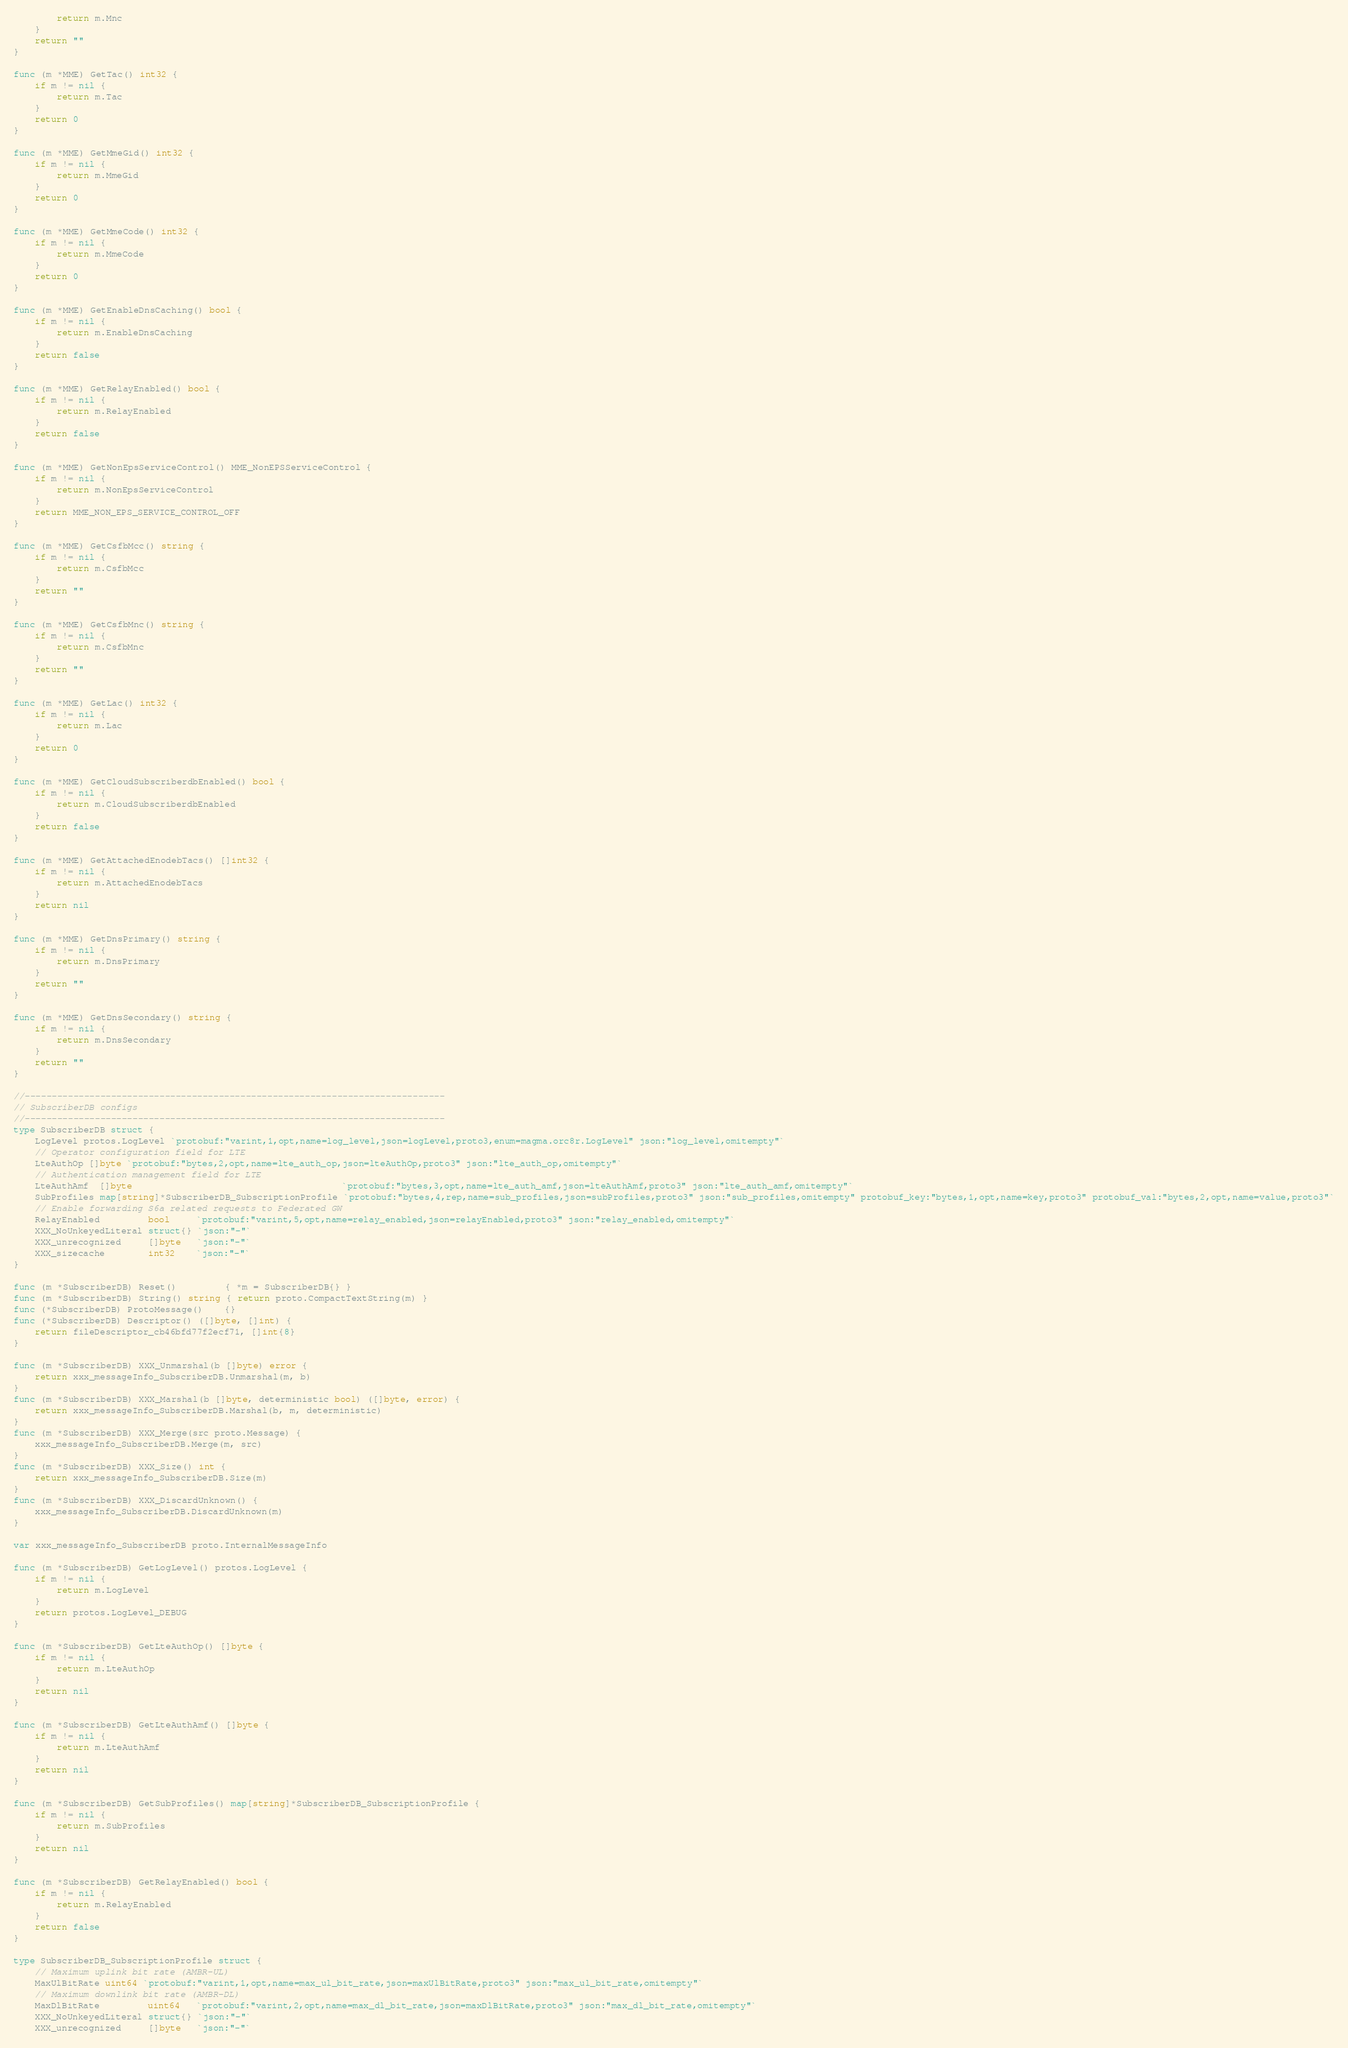<code> <loc_0><loc_0><loc_500><loc_500><_Go_>		return m.Mnc
	}
	return ""
}

func (m *MME) GetTac() int32 {
	if m != nil {
		return m.Tac
	}
	return 0
}

func (m *MME) GetMmeGid() int32 {
	if m != nil {
		return m.MmeGid
	}
	return 0
}

func (m *MME) GetMmeCode() int32 {
	if m != nil {
		return m.MmeCode
	}
	return 0
}

func (m *MME) GetEnableDnsCaching() bool {
	if m != nil {
		return m.EnableDnsCaching
	}
	return false
}

func (m *MME) GetRelayEnabled() bool {
	if m != nil {
		return m.RelayEnabled
	}
	return false
}

func (m *MME) GetNonEpsServiceControl() MME_NonEPSServiceControl {
	if m != nil {
		return m.NonEpsServiceControl
	}
	return MME_NON_EPS_SERVICE_CONTROL_OFF
}

func (m *MME) GetCsfbMcc() string {
	if m != nil {
		return m.CsfbMcc
	}
	return ""
}

func (m *MME) GetCsfbMnc() string {
	if m != nil {
		return m.CsfbMnc
	}
	return ""
}

func (m *MME) GetLac() int32 {
	if m != nil {
		return m.Lac
	}
	return 0
}

func (m *MME) GetCloudSubscriberdbEnabled() bool {
	if m != nil {
		return m.CloudSubscriberdbEnabled
	}
	return false
}

func (m *MME) GetAttachedEnodebTacs() []int32 {
	if m != nil {
		return m.AttachedEnodebTacs
	}
	return nil
}

func (m *MME) GetDnsPrimary() string {
	if m != nil {
		return m.DnsPrimary
	}
	return ""
}

func (m *MME) GetDnsSecondary() string {
	if m != nil {
		return m.DnsSecondary
	}
	return ""
}

//------------------------------------------------------------------------------
// SubscriberDB configs
//------------------------------------------------------------------------------
type SubscriberDB struct {
	LogLevel protos.LogLevel `protobuf:"varint,1,opt,name=log_level,json=logLevel,proto3,enum=magma.orc8r.LogLevel" json:"log_level,omitempty"`
	// Operator configuration field for LTE
	LteAuthOp []byte `protobuf:"bytes,2,opt,name=lte_auth_op,json=lteAuthOp,proto3" json:"lte_auth_op,omitempty"`
	// Authentication management field for LTE
	LteAuthAmf  []byte                                       `protobuf:"bytes,3,opt,name=lte_auth_amf,json=lteAuthAmf,proto3" json:"lte_auth_amf,omitempty"`
	SubProfiles map[string]*SubscriberDB_SubscriptionProfile `protobuf:"bytes,4,rep,name=sub_profiles,json=subProfiles,proto3" json:"sub_profiles,omitempty" protobuf_key:"bytes,1,opt,name=key,proto3" protobuf_val:"bytes,2,opt,name=value,proto3"`
	// Enable forwarding S6a related requests to Federated GW
	RelayEnabled         bool     `protobuf:"varint,5,opt,name=relay_enabled,json=relayEnabled,proto3" json:"relay_enabled,omitempty"`
	XXX_NoUnkeyedLiteral struct{} `json:"-"`
	XXX_unrecognized     []byte   `json:"-"`
	XXX_sizecache        int32    `json:"-"`
}

func (m *SubscriberDB) Reset()         { *m = SubscriberDB{} }
func (m *SubscriberDB) String() string { return proto.CompactTextString(m) }
func (*SubscriberDB) ProtoMessage()    {}
func (*SubscriberDB) Descriptor() ([]byte, []int) {
	return fileDescriptor_cb46bfd77f2ecf71, []int{8}
}

func (m *SubscriberDB) XXX_Unmarshal(b []byte) error {
	return xxx_messageInfo_SubscriberDB.Unmarshal(m, b)
}
func (m *SubscriberDB) XXX_Marshal(b []byte, deterministic bool) ([]byte, error) {
	return xxx_messageInfo_SubscriberDB.Marshal(b, m, deterministic)
}
func (m *SubscriberDB) XXX_Merge(src proto.Message) {
	xxx_messageInfo_SubscriberDB.Merge(m, src)
}
func (m *SubscriberDB) XXX_Size() int {
	return xxx_messageInfo_SubscriberDB.Size(m)
}
func (m *SubscriberDB) XXX_DiscardUnknown() {
	xxx_messageInfo_SubscriberDB.DiscardUnknown(m)
}

var xxx_messageInfo_SubscriberDB proto.InternalMessageInfo

func (m *SubscriberDB) GetLogLevel() protos.LogLevel {
	if m != nil {
		return m.LogLevel
	}
	return protos.LogLevel_DEBUG
}

func (m *SubscriberDB) GetLteAuthOp() []byte {
	if m != nil {
		return m.LteAuthOp
	}
	return nil
}

func (m *SubscriberDB) GetLteAuthAmf() []byte {
	if m != nil {
		return m.LteAuthAmf
	}
	return nil
}

func (m *SubscriberDB) GetSubProfiles() map[string]*SubscriberDB_SubscriptionProfile {
	if m != nil {
		return m.SubProfiles
	}
	return nil
}

func (m *SubscriberDB) GetRelayEnabled() bool {
	if m != nil {
		return m.RelayEnabled
	}
	return false
}

type SubscriberDB_SubscriptionProfile struct {
	// Maximum uplink bit rate (AMBR-UL)
	MaxUlBitRate uint64 `protobuf:"varint,1,opt,name=max_ul_bit_rate,json=maxUlBitRate,proto3" json:"max_ul_bit_rate,omitempty"`
	// Maximum downlink bit rate (AMBR-DL)
	MaxDlBitRate         uint64   `protobuf:"varint,2,opt,name=max_dl_bit_rate,json=maxDlBitRate,proto3" json:"max_dl_bit_rate,omitempty"`
	XXX_NoUnkeyedLiteral struct{} `json:"-"`
	XXX_unrecognized     []byte   `json:"-"`</code> 